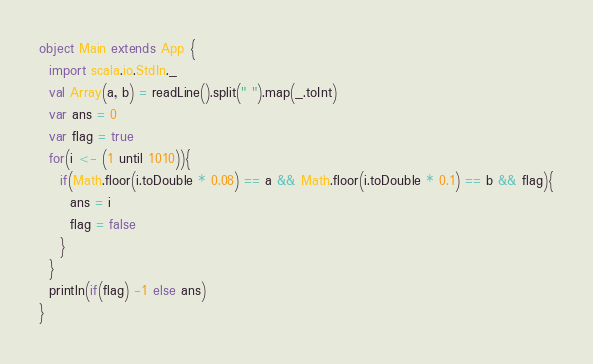<code> <loc_0><loc_0><loc_500><loc_500><_Scala_>object Main extends App {
  import scala.io.StdIn._
  val Array(a, b) = readLine().split(" ").map(_.toInt)
  var ans = 0
  var flag = true
  for(i <- (1 until 1010)){
    if(Math.floor(i.toDouble * 0.08) == a && Math.floor(i.toDouble * 0.1) == b && flag){
      ans = i
      flag = false
    }
  }
  println(if(flag) -1 else ans)
}</code> 